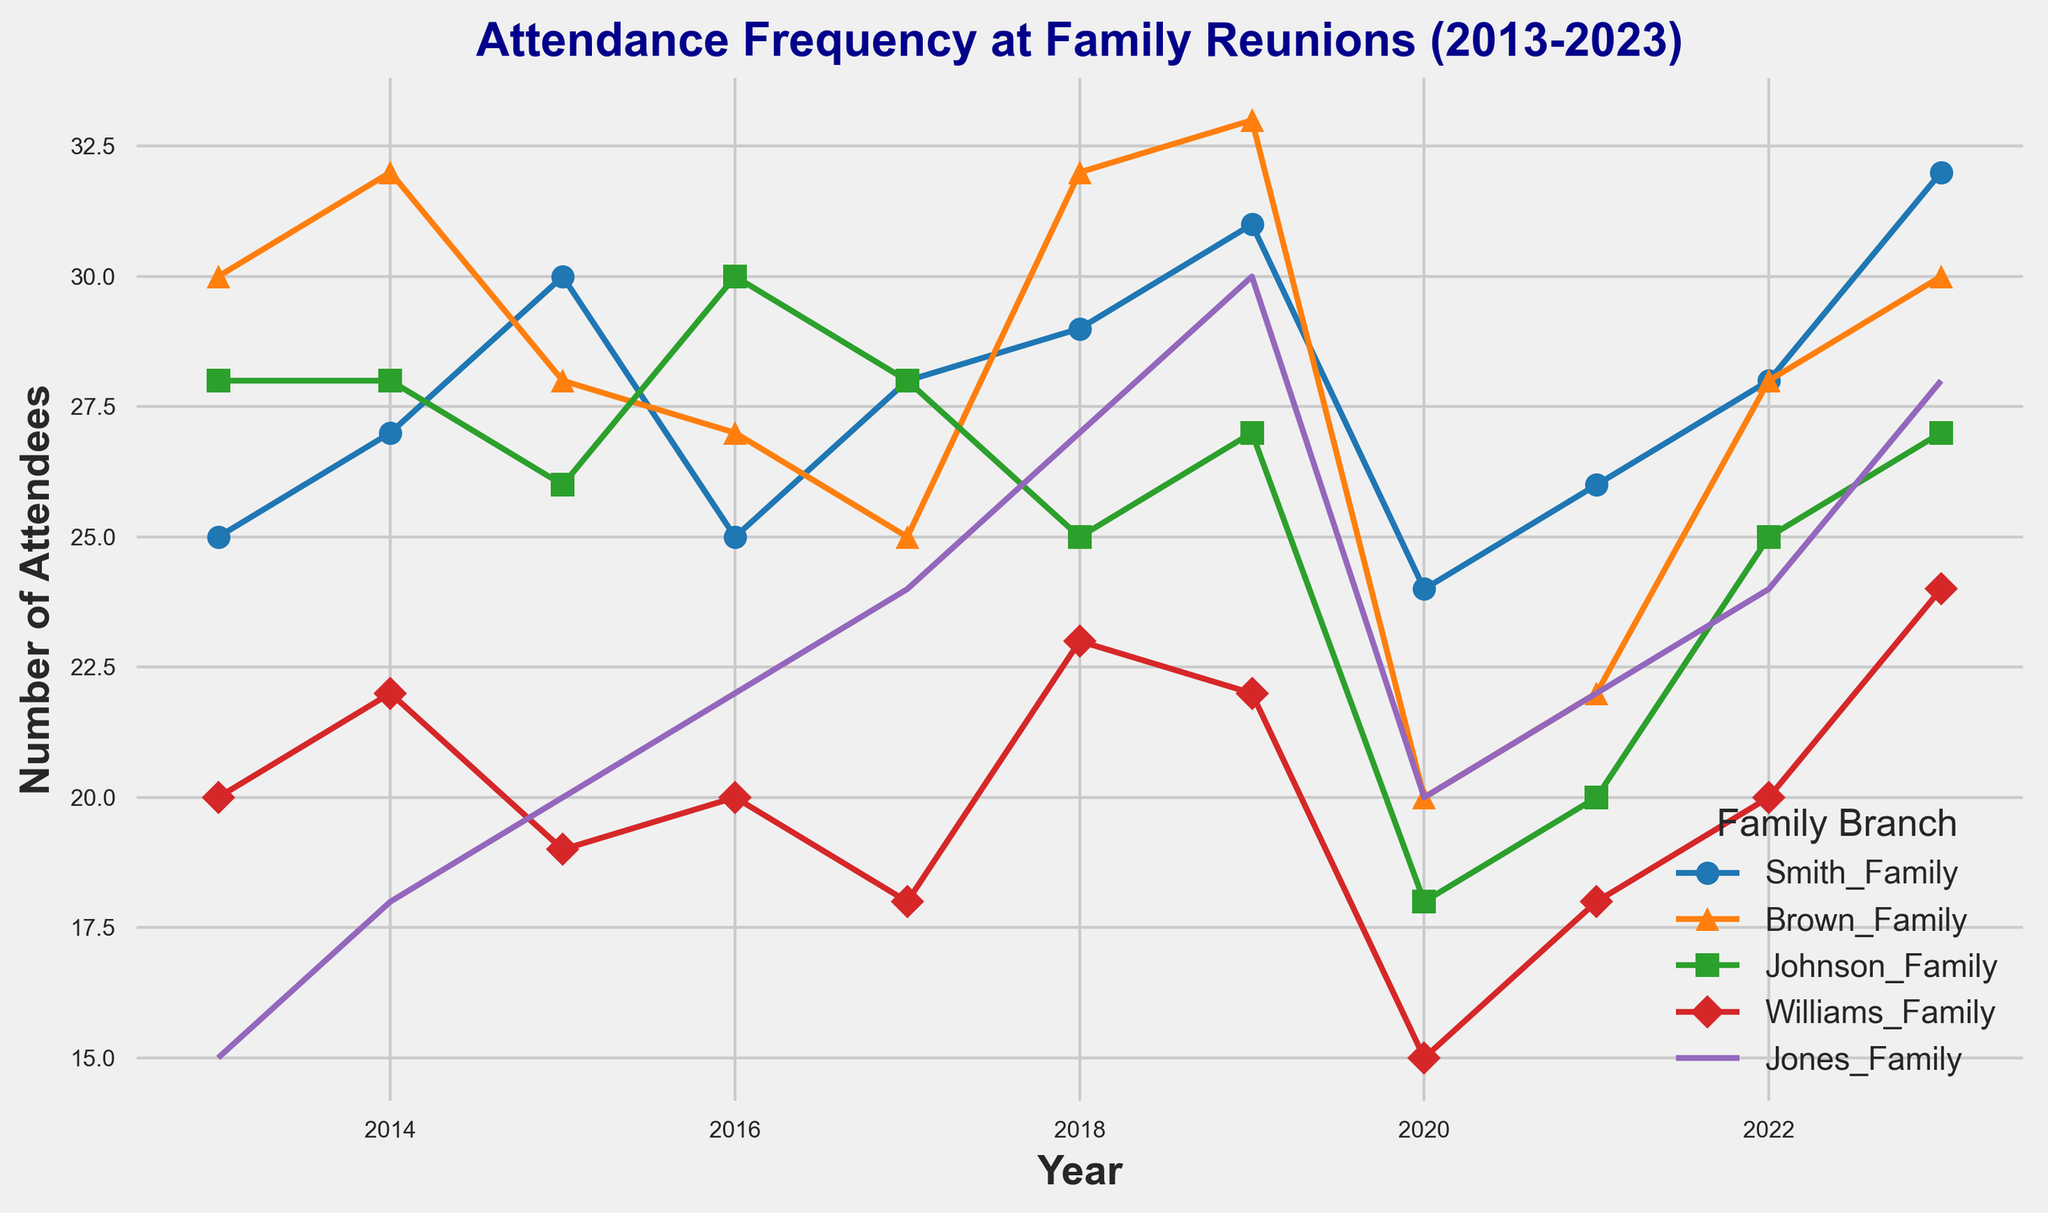How has the Smith Family's attendance changed from 2013 to 2023? The Smith Family's attendance in 2013 was 25 and in 2023 it is 32. To determine the change, subtract the 2013 value from the 2023 value (32 - 25).
Answer: Increased by 7 Which family had the highest attendance in 2023? Looking at the family attendance values in 2023, the highest number is 32, which corresponds to the Smith Family.
Answer: Smith Family Between the Brown Family and the Johnson Family, which one had a more significant drop in attendance between 2019 and 2020? Comparing the values from 2019 and 2020, the Brown Family's attendance dropped from 33 to 20 (a decrease of 13), while the Johnson Family's attendance dropped from 27 to 18 (a decrease of 9).
Answer: Brown Family What is the average attendance of the Williams Family over the decade? Sum up the attendance of the Williams Family over the years and divide by the number of years: (20 + 22 + 19 + 20 + 18 + 23 + 22 + 15 + 18 + 20 + 24) / 11. This gives (201) / 11.
Answer: 18.27 Which family had the most consistent attendance (smallest fluctuation) over the decade? To evaluate consistency, check the ranges (highest minus lowest attendance) for each family. The ranges are: Smith (32 - 24 = 8), Brown (33 - 20 = 13), Johnson (30 - 18 = 12), Williams (24 - 15 = 9), Jones (30 - 15 = 15). The family with the smallest range is the Smith Family.
Answer: Smith Family In which year did most families have their highest attendance? By checking each family's yearly attendance, you find the highest values for Smith (2023), Brown (2019), Johnson (2016), Williams (2023), and Jones (2019). The year that is most frequent among these is 2019.
Answer: 2019 How did the Johnson Family's attendance in 2020 compare to its average attendance for the entire period? Calculate the Johnson Family's average attendance over the decade by (28 + 28 + 26 + 30 + 28 + 25 + 27 + 18 + 20 + 25 + 27) / 11 to get approximately 25.27. In 2020, their attendance was 18, which is lower than the average.
Answer: Below average Which family had the largest increase in attendance from one year to the next? Check the annual changes and find the largest differences. The Brown Family's increase from 2020 to 2021 was the most significant, going from 20 to 22 (an increase of 10).
Answer: Brown Family What was the combined total attendance of all families in 2019? Add the attendance values for all families in 2019: (31 + 33 + 27 + 22 + 30) = 143.
Answer: 143 When did the Jones Family exceed 25 attendees for the first time in the decade? Reviewing the Jones Family's attendance data, they first exceeded 25 attendees in 2018.
Answer: 2018 